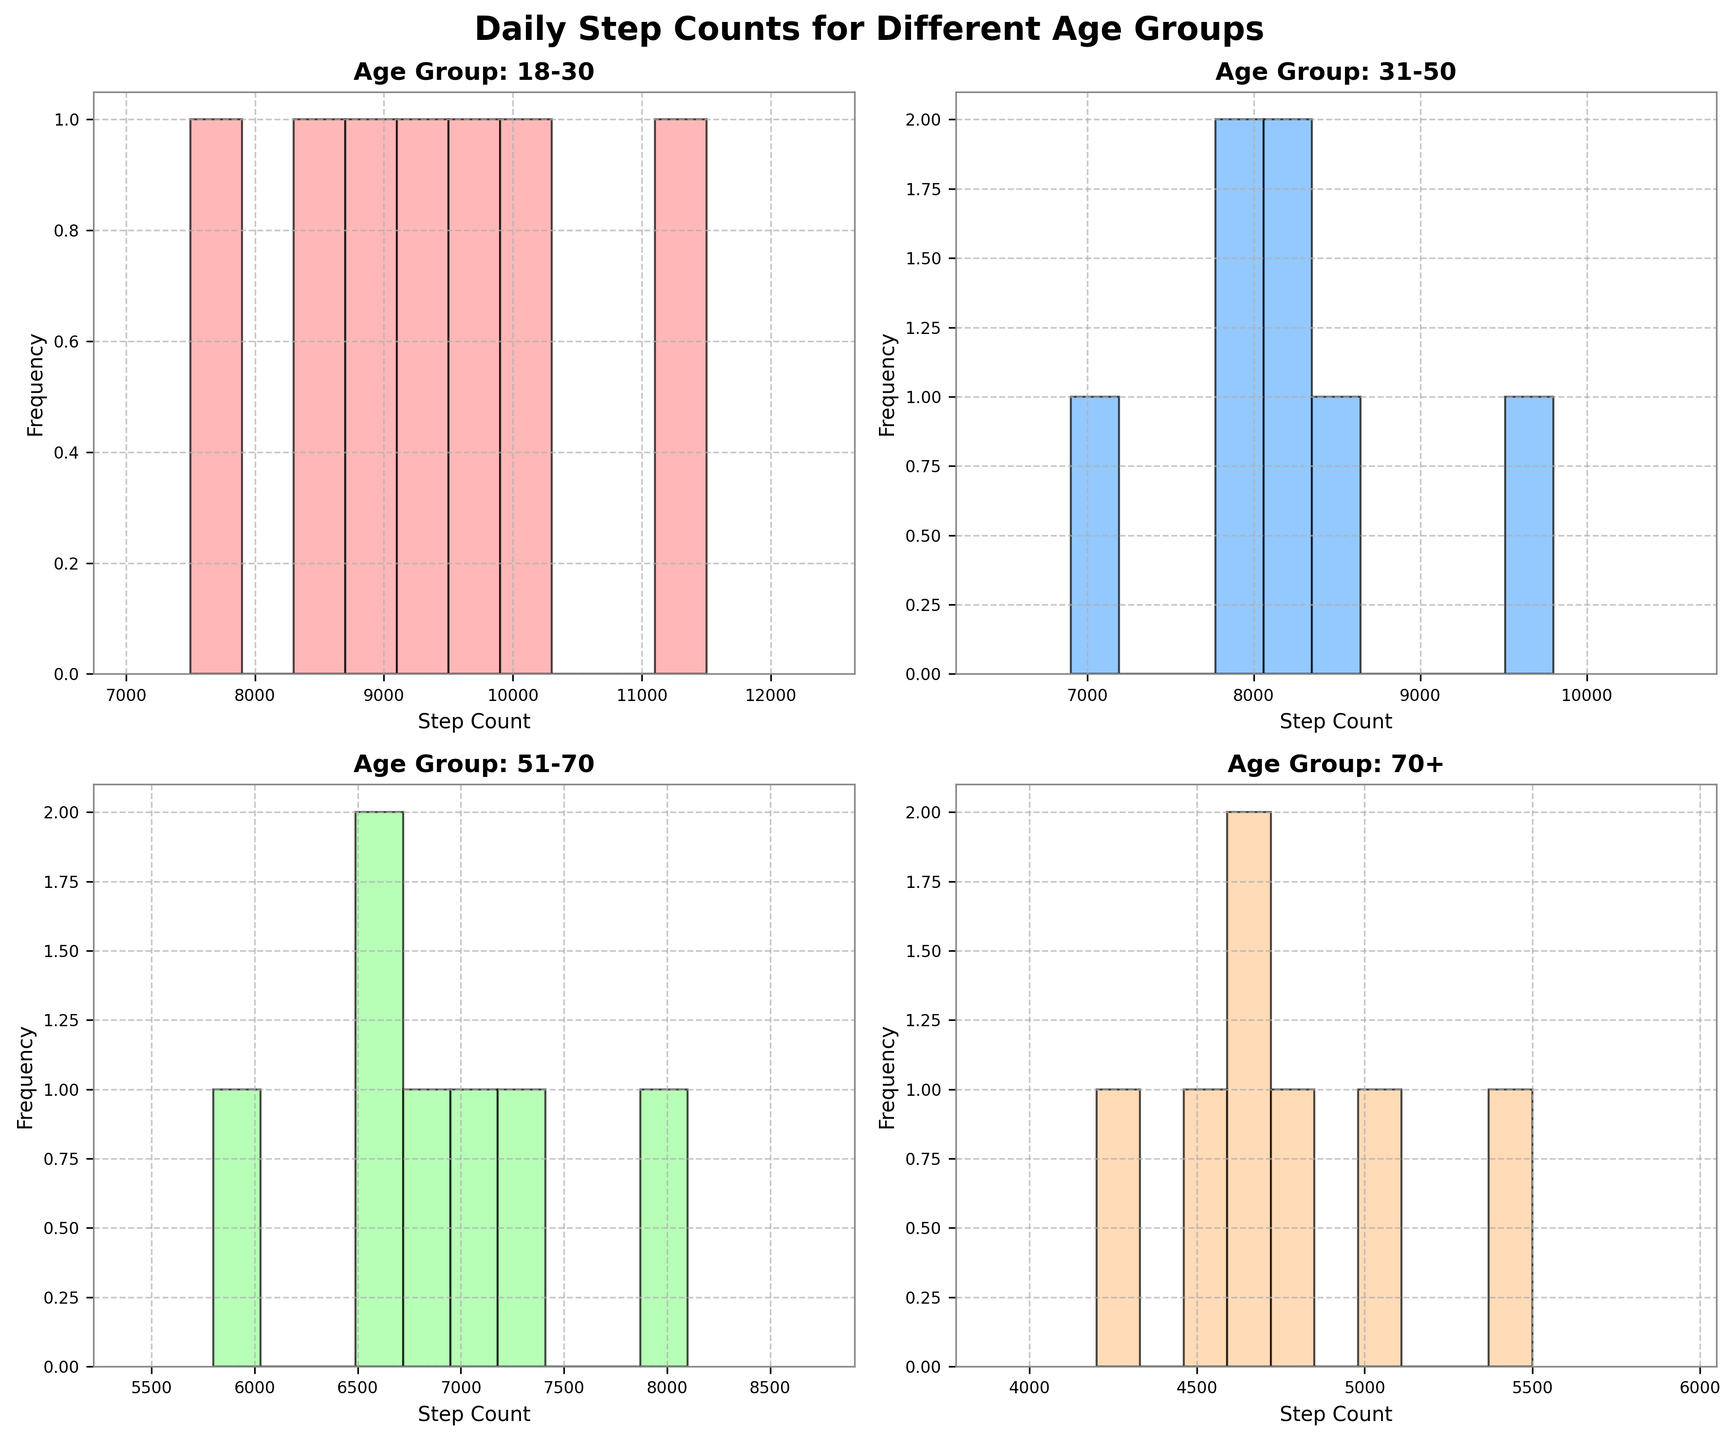What is the title of the figure? The title of the figure is at the top and reads "Daily Step Counts for Different Age Groups".
Answer: Daily Step Counts for Different Age Groups How many age groups are compared in the figure? By examining the subplots, we see each one corresponds to a different age group. There are four age groups in total.
Answer: Four Which age group has the highest step count on average? To determine this, we can visually inspect the histograms to see which one shows higher step counts more frequently. The 18-30 age group's histogram peaks at higher step counts compared to others.
Answer: 18-30 What color is used for the 31-50 age group in the histogram? The color of each histogram is different and the 31-50 age group's subplot is colored in light blue.
Answer: Light blue Which day has the highest step count for the 51-70 age group? By inspecting the histogram for the 51-70 age group, the highest peak is around Saturday, suggesting the highest step count is on Saturday.
Answer: Saturday Does the 70+ age group have higher step counts on weekends compared to weekdays? By inspecting the histogram for the 70+ age group, it can be seen that step counts on weekends (Saturday and Sunday) are generally lower compared to weekdays, with peaks on weekdays being higher.
Answer: No Compare the highest step count of the 18-30 age group with the highest step count of the 31-50 age group. Which group has a higher maximum step count? By looking at the histograms for these two groups, the 18-30 age group has a peak around 11500 on Saturday, which is higher than the 31-50 age group's peak around 9800 on Saturday.
Answer: 18-30 Is there a day where the 70+ age group exceeds 5000 steps? By examining the histogram for the 70+ age group, none of the days' bins exceed the 5000-step mark.
Answer: No What is the range of step counts for the 18-30 age group? The histogram shows step counts ranging from about 7500 on Sunday to 11500 on Saturday. Calculating the range, 11500 - 7500 = 4000.
Answer: 4000 Which age group shows the widest variation in step counts? The variation is seen through the spread of bins in each histogram. The 18-30 age group shows the widest range with step counts from 7500 to 11500.
Answer: 18-30 